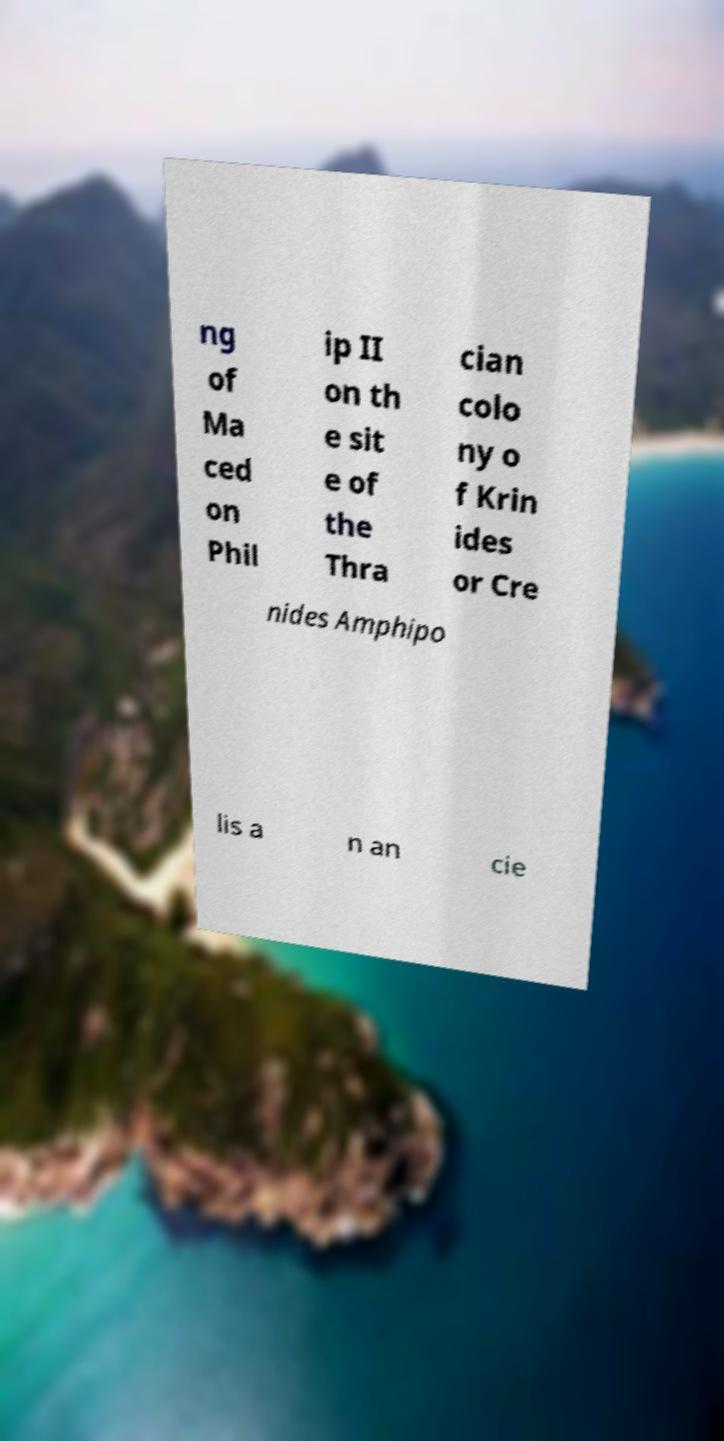Could you assist in decoding the text presented in this image and type it out clearly? ng of Ma ced on Phil ip II on th e sit e of the Thra cian colo ny o f Krin ides or Cre nides Amphipo lis a n an cie 